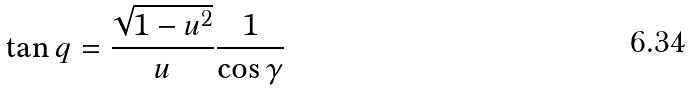Convert formula to latex. <formula><loc_0><loc_0><loc_500><loc_500>\tan q = \frac { \sqrt { 1 - u ^ { 2 } } } { u } \frac { 1 } { \cos \gamma }</formula> 